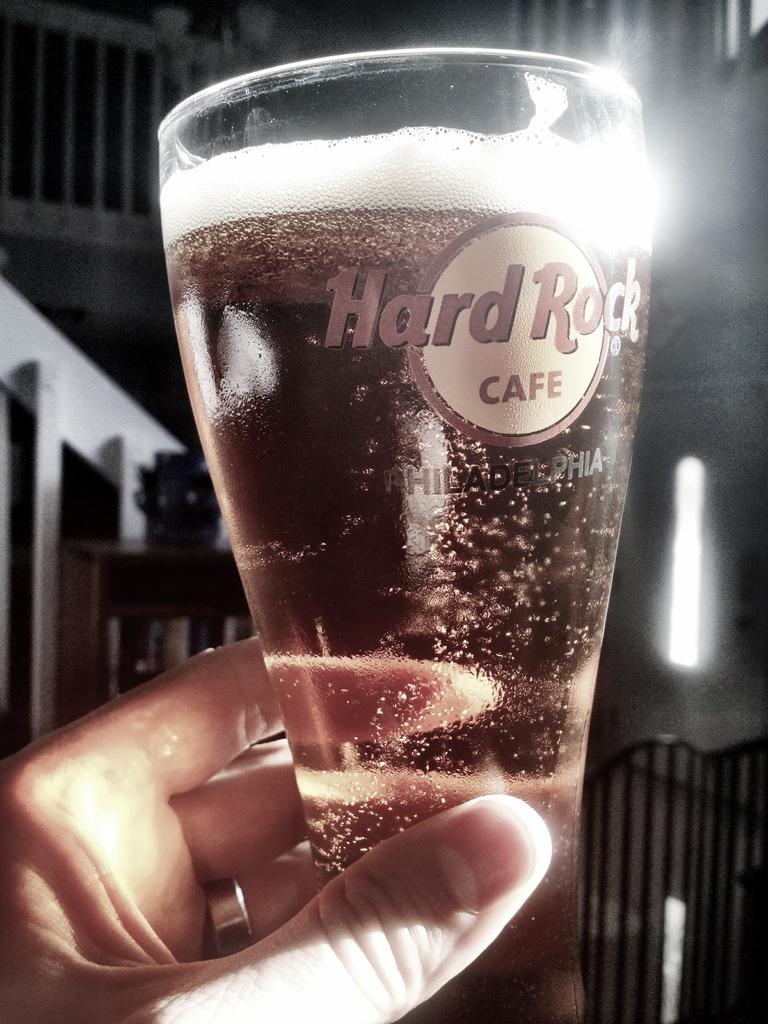What cafe is this glass from?
Offer a very short reply. Hard rock. 